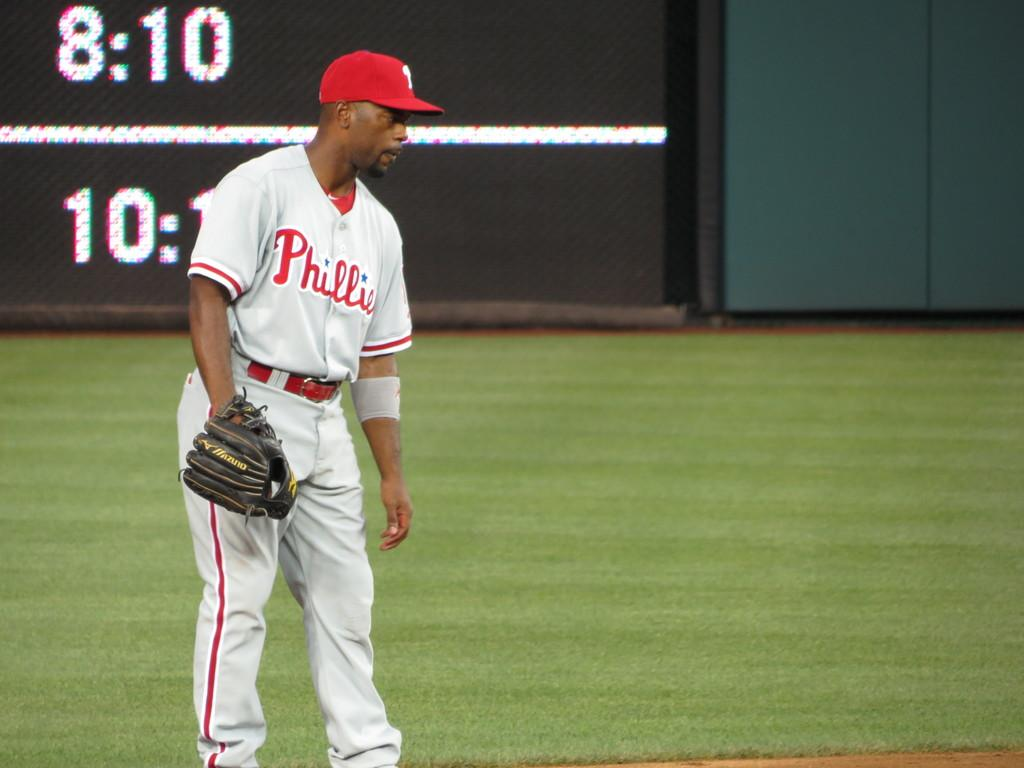Provide a one-sentence caption for the provided image. A Philadelphia Phillies player takes his glove off between plays. 